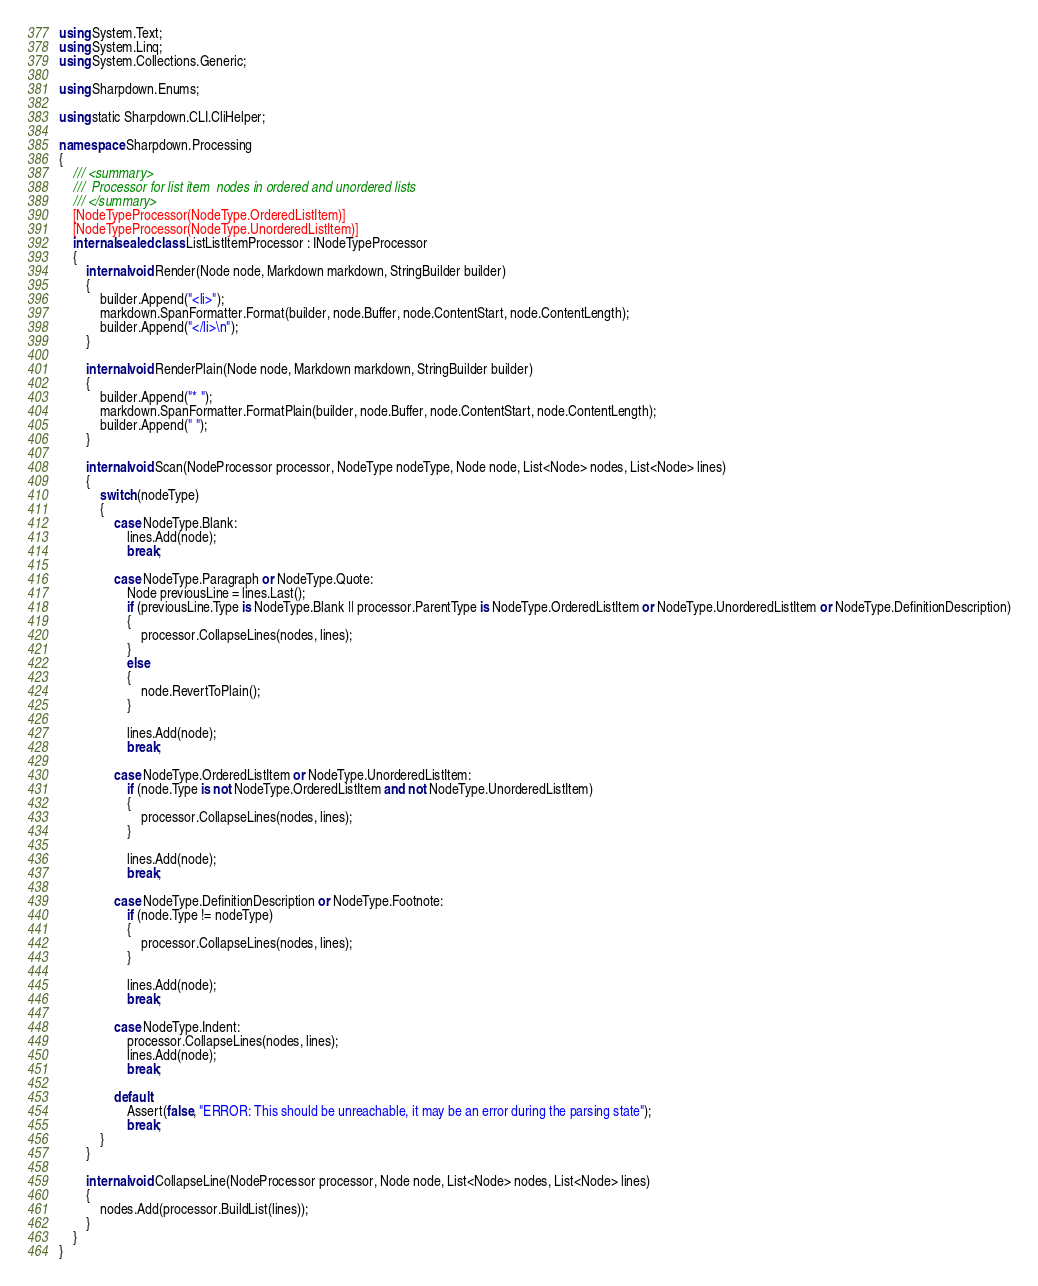Convert code to text. <code><loc_0><loc_0><loc_500><loc_500><_C#_>using System.Text;
using System.Linq;
using System.Collections.Generic;

using Sharpdown.Enums;

using static Sharpdown.CLI.CliHelper;

namespace Sharpdown.Processing
{
    /// <summary>
    ///  Processor for list item  nodes in ordered and unordered lists
    /// </summary>
    [NodeTypeProcessor(NodeType.OrderedListItem)]
    [NodeTypeProcessor(NodeType.UnorderedListItem)]
    internal sealed class ListListItemProcessor : INodeTypeProcessor
    {
        internal void Render(Node node, Markdown markdown, StringBuilder builder)
        {
            builder.Append("<li>");
            markdown.SpanFormatter.Format(builder, node.Buffer, node.ContentStart, node.ContentLength);
            builder.Append("</li>\n");
        }

        internal void RenderPlain(Node node, Markdown markdown, StringBuilder builder)
        {
            builder.Append("* ");
            markdown.SpanFormatter.FormatPlain(builder, node.Buffer, node.ContentStart, node.ContentLength);
            builder.Append(" ");
        }

        internal void Scan(NodeProcessor processor, NodeType nodeType, Node node, List<Node> nodes, List<Node> lines)
        {
            switch (nodeType)
            {
                case NodeType.Blank:
                    lines.Add(node);
                    break;

                case NodeType.Paragraph or NodeType.Quote:
                    Node previousLine = lines.Last();
                    if (previousLine.Type is NodeType.Blank || processor.ParentType is NodeType.OrderedListItem or NodeType.UnorderedListItem or NodeType.DefinitionDescription)
                    {
                        processor.CollapseLines(nodes, lines);
                    }
                    else
                    {
                        node.RevertToPlain();
                    }

                    lines.Add(node);
                    break;

                case NodeType.OrderedListItem or NodeType.UnorderedListItem:
                    if (node.Type is not NodeType.OrderedListItem and not NodeType.UnorderedListItem)
                    {
                        processor.CollapseLines(nodes, lines);
                    }

                    lines.Add(node);
                    break;

                case NodeType.DefinitionDescription or NodeType.Footnote:
                    if (node.Type != nodeType)
                    {
                        processor.CollapseLines(nodes, lines);
                    }

                    lines.Add(node);
                    break;

                case NodeType.Indent:
                    processor.CollapseLines(nodes, lines);
                    lines.Add(node);
                    break;

                default:
                    Assert(false, "ERROR: This should be unreachable, it may be an error during the parsing state");
                    break;
            }
        }

        internal void CollapseLine(NodeProcessor processor, Node node, List<Node> nodes, List<Node> lines)
        {
            nodes.Add(processor.BuildList(lines));
        }
    }
}</code> 